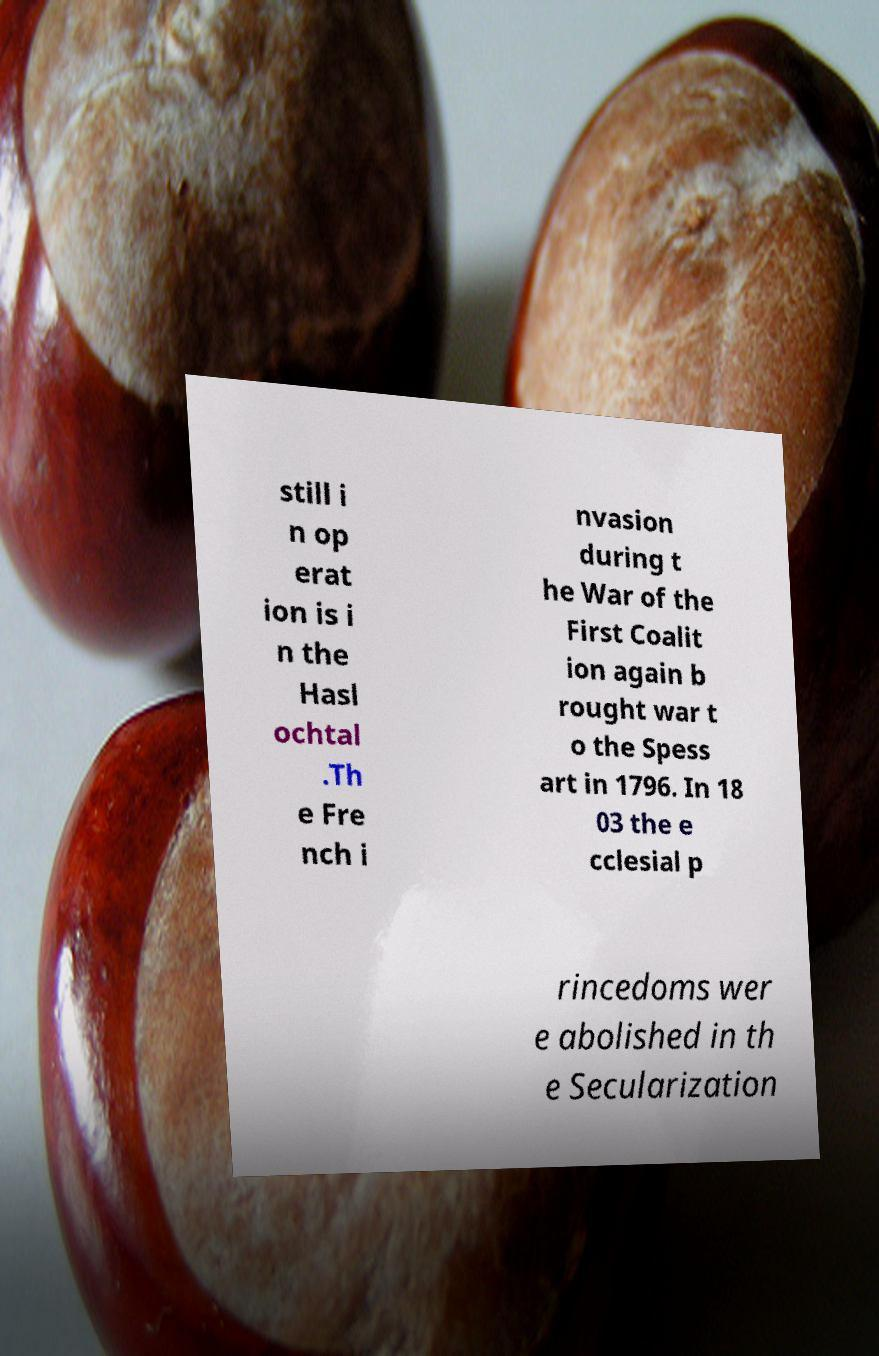Can you read and provide the text displayed in the image?This photo seems to have some interesting text. Can you extract and type it out for me? still i n op erat ion is i n the Hasl ochtal .Th e Fre nch i nvasion during t he War of the First Coalit ion again b rought war t o the Spess art in 1796. In 18 03 the e cclesial p rincedoms wer e abolished in th e Secularization 